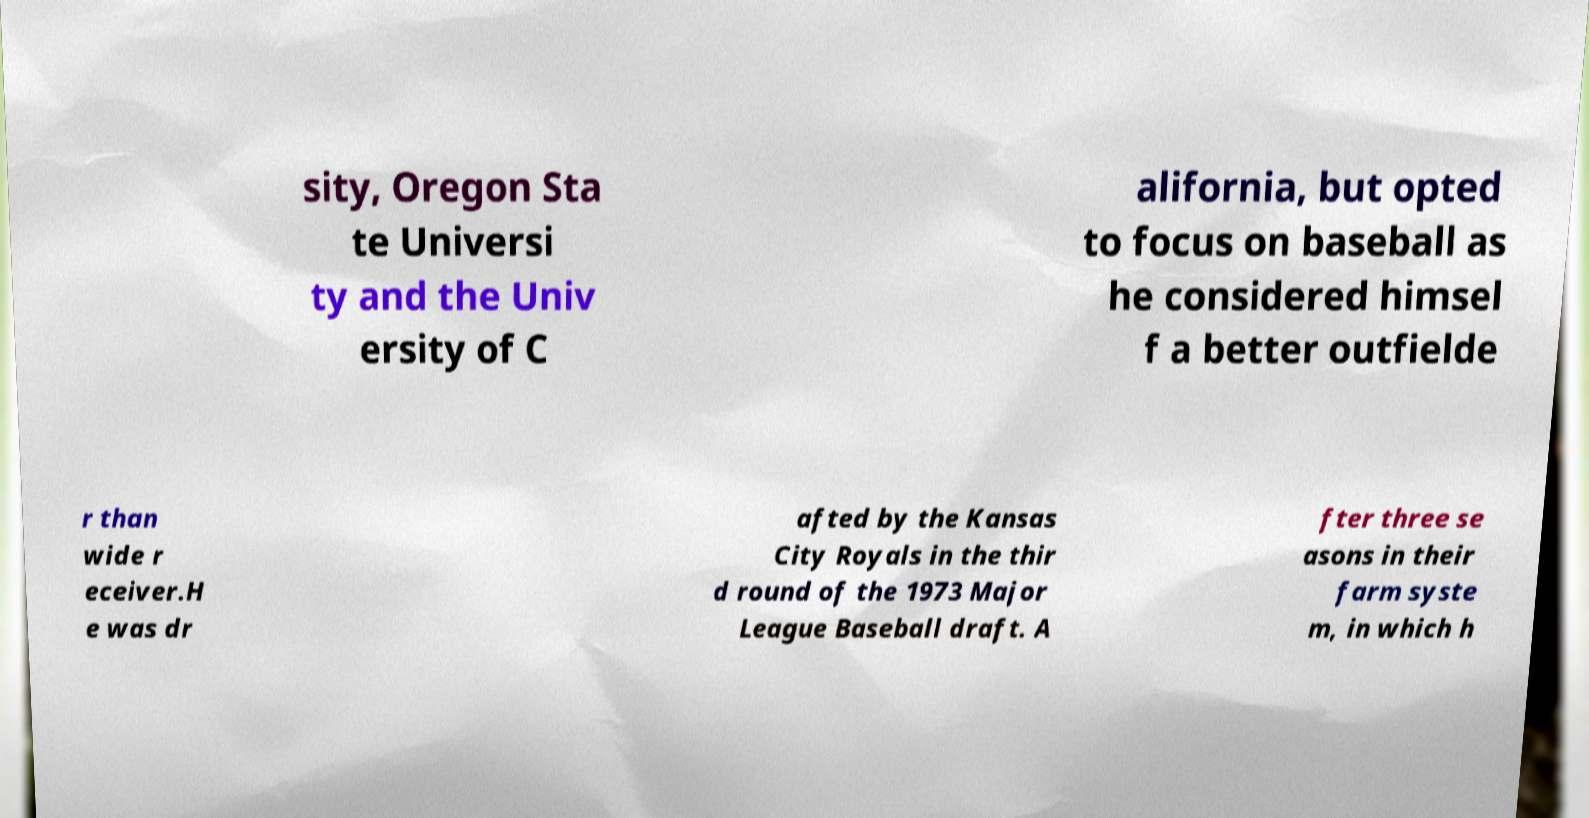Please read and relay the text visible in this image. What does it say? sity, Oregon Sta te Universi ty and the Univ ersity of C alifornia, but opted to focus on baseball as he considered himsel f a better outfielde r than wide r eceiver.H e was dr afted by the Kansas City Royals in the thir d round of the 1973 Major League Baseball draft. A fter three se asons in their farm syste m, in which h 